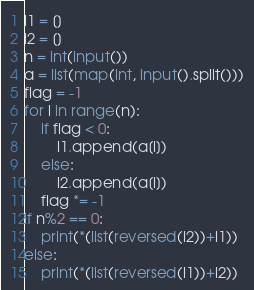Convert code to text. <code><loc_0><loc_0><loc_500><loc_500><_Python_>l1 = []
l2 = []
n = int(input())
a = list(map(int, input().split()))
flag = -1
for i in range(n):
    if flag < 0:
        l1.append(a[i])
    else:
        l2.append(a[i])
    flag *= -1
if n%2 == 0:
    print(*(list(reversed(l2))+l1))
else:
    print(*(list(reversed(l1))+l2))</code> 